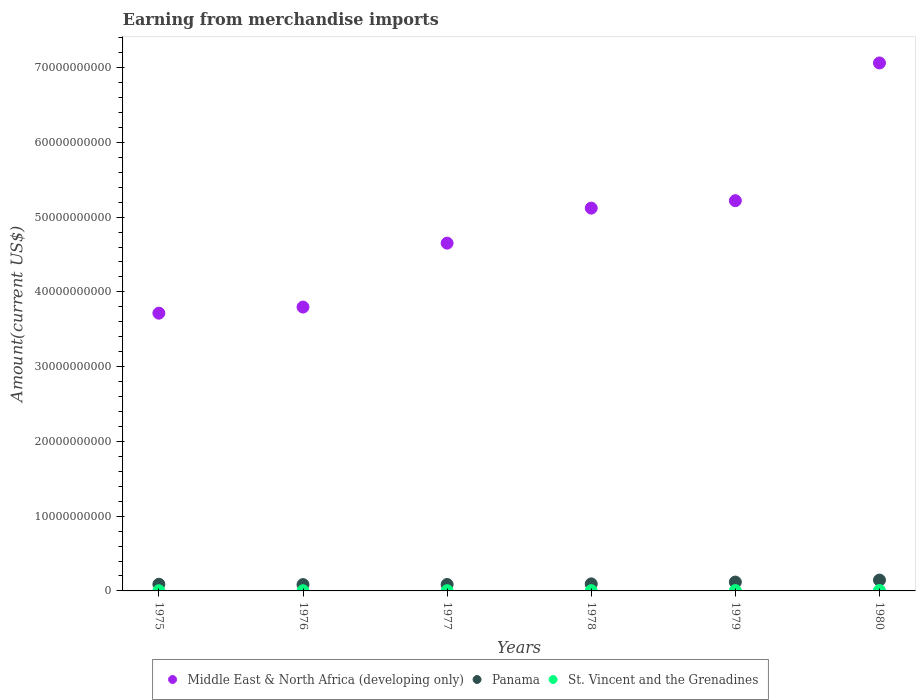How many different coloured dotlines are there?
Keep it short and to the point. 3. Is the number of dotlines equal to the number of legend labels?
Keep it short and to the point. Yes. What is the amount earned from merchandise imports in Middle East & North Africa (developing only) in 1980?
Offer a terse response. 7.06e+1. Across all years, what is the maximum amount earned from merchandise imports in Middle East & North Africa (developing only)?
Ensure brevity in your answer.  7.06e+1. Across all years, what is the minimum amount earned from merchandise imports in Panama?
Provide a short and direct response. 8.48e+08. In which year was the amount earned from merchandise imports in St. Vincent and the Grenadines minimum?
Make the answer very short. 1976. What is the total amount earned from merchandise imports in Panama in the graph?
Offer a very short reply. 6.18e+09. What is the difference between the amount earned from merchandise imports in Middle East & North Africa (developing only) in 1978 and that in 1979?
Provide a succinct answer. -9.95e+08. What is the difference between the amount earned from merchandise imports in Panama in 1979 and the amount earned from merchandise imports in St. Vincent and the Grenadines in 1980?
Ensure brevity in your answer.  1.13e+09. What is the average amount earned from merchandise imports in Panama per year?
Give a very brief answer. 1.03e+09. In the year 1977, what is the difference between the amount earned from merchandise imports in Middle East & North Africa (developing only) and amount earned from merchandise imports in Panama?
Offer a very short reply. 4.57e+1. What is the ratio of the amount earned from merchandise imports in Panama in 1977 to that in 1979?
Make the answer very short. 0.73. Is the amount earned from merchandise imports in Panama in 1978 less than that in 1979?
Keep it short and to the point. Yes. What is the difference between the highest and the second highest amount earned from merchandise imports in Panama?
Ensure brevity in your answer.  2.65e+08. What is the difference between the highest and the lowest amount earned from merchandise imports in Middle East & North Africa (developing only)?
Offer a very short reply. 3.35e+1. In how many years, is the amount earned from merchandise imports in Panama greater than the average amount earned from merchandise imports in Panama taken over all years?
Your response must be concise. 2. Is the sum of the amount earned from merchandise imports in Middle East & North Africa (developing only) in 1975 and 1976 greater than the maximum amount earned from merchandise imports in St. Vincent and the Grenadines across all years?
Keep it short and to the point. Yes. Does the amount earned from merchandise imports in St. Vincent and the Grenadines monotonically increase over the years?
Offer a very short reply. No. Is the amount earned from merchandise imports in Middle East & North Africa (developing only) strictly less than the amount earned from merchandise imports in Panama over the years?
Provide a short and direct response. No. How many years are there in the graph?
Ensure brevity in your answer.  6. Does the graph contain grids?
Your answer should be very brief. No. What is the title of the graph?
Ensure brevity in your answer.  Earning from merchandise imports. What is the label or title of the Y-axis?
Ensure brevity in your answer.  Amount(current US$). What is the Amount(current US$) of Middle East & North Africa (developing only) in 1975?
Make the answer very short. 3.72e+1. What is the Amount(current US$) of Panama in 1975?
Offer a terse response. 8.92e+08. What is the Amount(current US$) of St. Vincent and the Grenadines in 1975?
Keep it short and to the point. 2.48e+07. What is the Amount(current US$) of Middle East & North Africa (developing only) in 1976?
Offer a terse response. 3.80e+1. What is the Amount(current US$) in Panama in 1976?
Your answer should be compact. 8.48e+08. What is the Amount(current US$) of St. Vincent and the Grenadines in 1976?
Your answer should be compact. 2.37e+07. What is the Amount(current US$) in Middle East & North Africa (developing only) in 1977?
Provide a succinct answer. 4.65e+1. What is the Amount(current US$) of Panama in 1977?
Your response must be concise. 8.61e+08. What is the Amount(current US$) of St. Vincent and the Grenadines in 1977?
Give a very brief answer. 3.03e+07. What is the Amount(current US$) of Middle East & North Africa (developing only) in 1978?
Offer a terse response. 5.12e+1. What is the Amount(current US$) in Panama in 1978?
Make the answer very short. 9.42e+08. What is the Amount(current US$) in St. Vincent and the Grenadines in 1978?
Make the answer very short. 3.62e+07. What is the Amount(current US$) in Middle East & North Africa (developing only) in 1979?
Offer a very short reply. 5.22e+1. What is the Amount(current US$) in Panama in 1979?
Ensure brevity in your answer.  1.18e+09. What is the Amount(current US$) in St. Vincent and the Grenadines in 1979?
Give a very brief answer. 4.66e+07. What is the Amount(current US$) in Middle East & North Africa (developing only) in 1980?
Ensure brevity in your answer.  7.06e+1. What is the Amount(current US$) of Panama in 1980?
Give a very brief answer. 1.45e+09. What is the Amount(current US$) in St. Vincent and the Grenadines in 1980?
Ensure brevity in your answer.  5.70e+07. Across all years, what is the maximum Amount(current US$) of Middle East & North Africa (developing only)?
Make the answer very short. 7.06e+1. Across all years, what is the maximum Amount(current US$) of Panama?
Provide a succinct answer. 1.45e+09. Across all years, what is the maximum Amount(current US$) of St. Vincent and the Grenadines?
Offer a terse response. 5.70e+07. Across all years, what is the minimum Amount(current US$) in Middle East & North Africa (developing only)?
Your response must be concise. 3.72e+1. Across all years, what is the minimum Amount(current US$) of Panama?
Your response must be concise. 8.48e+08. Across all years, what is the minimum Amount(current US$) of St. Vincent and the Grenadines?
Give a very brief answer. 2.37e+07. What is the total Amount(current US$) of Middle East & North Africa (developing only) in the graph?
Offer a very short reply. 2.96e+11. What is the total Amount(current US$) in Panama in the graph?
Offer a terse response. 6.18e+09. What is the total Amount(current US$) in St. Vincent and the Grenadines in the graph?
Make the answer very short. 2.19e+08. What is the difference between the Amount(current US$) in Middle East & North Africa (developing only) in 1975 and that in 1976?
Your answer should be compact. -8.16e+08. What is the difference between the Amount(current US$) in Panama in 1975 and that in 1976?
Your answer should be very brief. 4.37e+07. What is the difference between the Amount(current US$) in St. Vincent and the Grenadines in 1975 and that in 1976?
Give a very brief answer. 1.12e+06. What is the difference between the Amount(current US$) of Middle East & North Africa (developing only) in 1975 and that in 1977?
Offer a very short reply. -9.37e+09. What is the difference between the Amount(current US$) of Panama in 1975 and that in 1977?
Make the answer very short. 3.08e+07. What is the difference between the Amount(current US$) of St. Vincent and the Grenadines in 1975 and that in 1977?
Provide a short and direct response. -5.49e+06. What is the difference between the Amount(current US$) in Middle East & North Africa (developing only) in 1975 and that in 1978?
Make the answer very short. -1.41e+1. What is the difference between the Amount(current US$) in Panama in 1975 and that in 1978?
Provide a succinct answer. -5.03e+07. What is the difference between the Amount(current US$) of St. Vincent and the Grenadines in 1975 and that in 1978?
Make the answer very short. -1.13e+07. What is the difference between the Amount(current US$) in Middle East & North Africa (developing only) in 1975 and that in 1979?
Provide a succinct answer. -1.50e+1. What is the difference between the Amount(current US$) of Panama in 1975 and that in 1979?
Provide a short and direct response. -2.92e+08. What is the difference between the Amount(current US$) in St. Vincent and the Grenadines in 1975 and that in 1979?
Your answer should be compact. -2.18e+07. What is the difference between the Amount(current US$) in Middle East & North Africa (developing only) in 1975 and that in 1980?
Ensure brevity in your answer.  -3.35e+1. What is the difference between the Amount(current US$) in Panama in 1975 and that in 1980?
Offer a terse response. -5.57e+08. What is the difference between the Amount(current US$) of St. Vincent and the Grenadines in 1975 and that in 1980?
Your response must be concise. -3.22e+07. What is the difference between the Amount(current US$) of Middle East & North Africa (developing only) in 1976 and that in 1977?
Provide a succinct answer. -8.55e+09. What is the difference between the Amount(current US$) of Panama in 1976 and that in 1977?
Offer a very short reply. -1.29e+07. What is the difference between the Amount(current US$) in St. Vincent and the Grenadines in 1976 and that in 1977?
Give a very brief answer. -6.61e+06. What is the difference between the Amount(current US$) in Middle East & North Africa (developing only) in 1976 and that in 1978?
Offer a terse response. -1.32e+1. What is the difference between the Amount(current US$) in Panama in 1976 and that in 1978?
Offer a very short reply. -9.41e+07. What is the difference between the Amount(current US$) in St. Vincent and the Grenadines in 1976 and that in 1978?
Provide a short and direct response. -1.25e+07. What is the difference between the Amount(current US$) in Middle East & North Africa (developing only) in 1976 and that in 1979?
Your answer should be compact. -1.42e+1. What is the difference between the Amount(current US$) of Panama in 1976 and that in 1979?
Make the answer very short. -3.36e+08. What is the difference between the Amount(current US$) of St. Vincent and the Grenadines in 1976 and that in 1979?
Your answer should be compact. -2.29e+07. What is the difference between the Amount(current US$) of Middle East & North Africa (developing only) in 1976 and that in 1980?
Offer a very short reply. -3.27e+1. What is the difference between the Amount(current US$) of Panama in 1976 and that in 1980?
Make the answer very short. -6.01e+08. What is the difference between the Amount(current US$) of St. Vincent and the Grenadines in 1976 and that in 1980?
Keep it short and to the point. -3.33e+07. What is the difference between the Amount(current US$) of Middle East & North Africa (developing only) in 1977 and that in 1978?
Give a very brief answer. -4.68e+09. What is the difference between the Amount(current US$) of Panama in 1977 and that in 1978?
Your response must be concise. -8.12e+07. What is the difference between the Amount(current US$) in St. Vincent and the Grenadines in 1977 and that in 1978?
Make the answer very short. -5.85e+06. What is the difference between the Amount(current US$) of Middle East & North Africa (developing only) in 1977 and that in 1979?
Your response must be concise. -5.68e+09. What is the difference between the Amount(current US$) of Panama in 1977 and that in 1979?
Provide a succinct answer. -3.23e+08. What is the difference between the Amount(current US$) of St. Vincent and the Grenadines in 1977 and that in 1979?
Offer a very short reply. -1.63e+07. What is the difference between the Amount(current US$) in Middle East & North Africa (developing only) in 1977 and that in 1980?
Provide a short and direct response. -2.41e+1. What is the difference between the Amount(current US$) in Panama in 1977 and that in 1980?
Ensure brevity in your answer.  -5.88e+08. What is the difference between the Amount(current US$) of St. Vincent and the Grenadines in 1977 and that in 1980?
Your response must be concise. -2.67e+07. What is the difference between the Amount(current US$) of Middle East & North Africa (developing only) in 1978 and that in 1979?
Provide a succinct answer. -9.95e+08. What is the difference between the Amount(current US$) in Panama in 1978 and that in 1979?
Ensure brevity in your answer.  -2.41e+08. What is the difference between the Amount(current US$) of St. Vincent and the Grenadines in 1978 and that in 1979?
Make the answer very short. -1.04e+07. What is the difference between the Amount(current US$) in Middle East & North Africa (developing only) in 1978 and that in 1980?
Provide a succinct answer. -1.94e+1. What is the difference between the Amount(current US$) of Panama in 1978 and that in 1980?
Ensure brevity in your answer.  -5.07e+08. What is the difference between the Amount(current US$) in St. Vincent and the Grenadines in 1978 and that in 1980?
Make the answer very short. -2.08e+07. What is the difference between the Amount(current US$) in Middle East & North Africa (developing only) in 1979 and that in 1980?
Make the answer very short. -1.84e+1. What is the difference between the Amount(current US$) of Panama in 1979 and that in 1980?
Your answer should be very brief. -2.65e+08. What is the difference between the Amount(current US$) of St. Vincent and the Grenadines in 1979 and that in 1980?
Your response must be concise. -1.04e+07. What is the difference between the Amount(current US$) in Middle East & North Africa (developing only) in 1975 and the Amount(current US$) in Panama in 1976?
Provide a succinct answer. 3.63e+1. What is the difference between the Amount(current US$) of Middle East & North Africa (developing only) in 1975 and the Amount(current US$) of St. Vincent and the Grenadines in 1976?
Your answer should be compact. 3.71e+1. What is the difference between the Amount(current US$) in Panama in 1975 and the Amount(current US$) in St. Vincent and the Grenadines in 1976?
Provide a short and direct response. 8.68e+08. What is the difference between the Amount(current US$) of Middle East & North Africa (developing only) in 1975 and the Amount(current US$) of Panama in 1977?
Make the answer very short. 3.63e+1. What is the difference between the Amount(current US$) of Middle East & North Africa (developing only) in 1975 and the Amount(current US$) of St. Vincent and the Grenadines in 1977?
Offer a very short reply. 3.71e+1. What is the difference between the Amount(current US$) in Panama in 1975 and the Amount(current US$) in St. Vincent and the Grenadines in 1977?
Your answer should be very brief. 8.62e+08. What is the difference between the Amount(current US$) in Middle East & North Africa (developing only) in 1975 and the Amount(current US$) in Panama in 1978?
Your response must be concise. 3.62e+1. What is the difference between the Amount(current US$) in Middle East & North Africa (developing only) in 1975 and the Amount(current US$) in St. Vincent and the Grenadines in 1978?
Your answer should be compact. 3.71e+1. What is the difference between the Amount(current US$) in Panama in 1975 and the Amount(current US$) in St. Vincent and the Grenadines in 1978?
Offer a very short reply. 8.56e+08. What is the difference between the Amount(current US$) in Middle East & North Africa (developing only) in 1975 and the Amount(current US$) in Panama in 1979?
Ensure brevity in your answer.  3.60e+1. What is the difference between the Amount(current US$) of Middle East & North Africa (developing only) in 1975 and the Amount(current US$) of St. Vincent and the Grenadines in 1979?
Make the answer very short. 3.71e+1. What is the difference between the Amount(current US$) in Panama in 1975 and the Amount(current US$) in St. Vincent and the Grenadines in 1979?
Offer a terse response. 8.45e+08. What is the difference between the Amount(current US$) of Middle East & North Africa (developing only) in 1975 and the Amount(current US$) of Panama in 1980?
Your answer should be compact. 3.57e+1. What is the difference between the Amount(current US$) of Middle East & North Africa (developing only) in 1975 and the Amount(current US$) of St. Vincent and the Grenadines in 1980?
Give a very brief answer. 3.71e+1. What is the difference between the Amount(current US$) of Panama in 1975 and the Amount(current US$) of St. Vincent and the Grenadines in 1980?
Your answer should be compact. 8.35e+08. What is the difference between the Amount(current US$) of Middle East & North Africa (developing only) in 1976 and the Amount(current US$) of Panama in 1977?
Provide a succinct answer. 3.71e+1. What is the difference between the Amount(current US$) in Middle East & North Africa (developing only) in 1976 and the Amount(current US$) in St. Vincent and the Grenadines in 1977?
Offer a very short reply. 3.79e+1. What is the difference between the Amount(current US$) in Panama in 1976 and the Amount(current US$) in St. Vincent and the Grenadines in 1977?
Your answer should be compact. 8.18e+08. What is the difference between the Amount(current US$) of Middle East & North Africa (developing only) in 1976 and the Amount(current US$) of Panama in 1978?
Keep it short and to the point. 3.70e+1. What is the difference between the Amount(current US$) of Middle East & North Africa (developing only) in 1976 and the Amount(current US$) of St. Vincent and the Grenadines in 1978?
Offer a very short reply. 3.79e+1. What is the difference between the Amount(current US$) in Panama in 1976 and the Amount(current US$) in St. Vincent and the Grenadines in 1978?
Ensure brevity in your answer.  8.12e+08. What is the difference between the Amount(current US$) of Middle East & North Africa (developing only) in 1976 and the Amount(current US$) of Panama in 1979?
Give a very brief answer. 3.68e+1. What is the difference between the Amount(current US$) in Middle East & North Africa (developing only) in 1976 and the Amount(current US$) in St. Vincent and the Grenadines in 1979?
Provide a succinct answer. 3.79e+1. What is the difference between the Amount(current US$) of Panama in 1976 and the Amount(current US$) of St. Vincent and the Grenadines in 1979?
Provide a short and direct response. 8.02e+08. What is the difference between the Amount(current US$) in Middle East & North Africa (developing only) in 1976 and the Amount(current US$) in Panama in 1980?
Keep it short and to the point. 3.65e+1. What is the difference between the Amount(current US$) of Middle East & North Africa (developing only) in 1976 and the Amount(current US$) of St. Vincent and the Grenadines in 1980?
Give a very brief answer. 3.79e+1. What is the difference between the Amount(current US$) in Panama in 1976 and the Amount(current US$) in St. Vincent and the Grenadines in 1980?
Offer a terse response. 7.91e+08. What is the difference between the Amount(current US$) of Middle East & North Africa (developing only) in 1977 and the Amount(current US$) of Panama in 1978?
Give a very brief answer. 4.56e+1. What is the difference between the Amount(current US$) of Middle East & North Africa (developing only) in 1977 and the Amount(current US$) of St. Vincent and the Grenadines in 1978?
Provide a succinct answer. 4.65e+1. What is the difference between the Amount(current US$) of Panama in 1977 and the Amount(current US$) of St. Vincent and the Grenadines in 1978?
Offer a very short reply. 8.25e+08. What is the difference between the Amount(current US$) in Middle East & North Africa (developing only) in 1977 and the Amount(current US$) in Panama in 1979?
Ensure brevity in your answer.  4.53e+1. What is the difference between the Amount(current US$) of Middle East & North Africa (developing only) in 1977 and the Amount(current US$) of St. Vincent and the Grenadines in 1979?
Your response must be concise. 4.65e+1. What is the difference between the Amount(current US$) of Panama in 1977 and the Amount(current US$) of St. Vincent and the Grenadines in 1979?
Keep it short and to the point. 8.15e+08. What is the difference between the Amount(current US$) of Middle East & North Africa (developing only) in 1977 and the Amount(current US$) of Panama in 1980?
Give a very brief answer. 4.51e+1. What is the difference between the Amount(current US$) of Middle East & North Africa (developing only) in 1977 and the Amount(current US$) of St. Vincent and the Grenadines in 1980?
Your answer should be compact. 4.65e+1. What is the difference between the Amount(current US$) of Panama in 1977 and the Amount(current US$) of St. Vincent and the Grenadines in 1980?
Offer a terse response. 8.04e+08. What is the difference between the Amount(current US$) of Middle East & North Africa (developing only) in 1978 and the Amount(current US$) of Panama in 1979?
Give a very brief answer. 5.00e+1. What is the difference between the Amount(current US$) in Middle East & North Africa (developing only) in 1978 and the Amount(current US$) in St. Vincent and the Grenadines in 1979?
Your response must be concise. 5.12e+1. What is the difference between the Amount(current US$) in Panama in 1978 and the Amount(current US$) in St. Vincent and the Grenadines in 1979?
Keep it short and to the point. 8.96e+08. What is the difference between the Amount(current US$) in Middle East & North Africa (developing only) in 1978 and the Amount(current US$) in Panama in 1980?
Keep it short and to the point. 4.98e+1. What is the difference between the Amount(current US$) of Middle East & North Africa (developing only) in 1978 and the Amount(current US$) of St. Vincent and the Grenadines in 1980?
Keep it short and to the point. 5.11e+1. What is the difference between the Amount(current US$) of Panama in 1978 and the Amount(current US$) of St. Vincent and the Grenadines in 1980?
Make the answer very short. 8.85e+08. What is the difference between the Amount(current US$) in Middle East & North Africa (developing only) in 1979 and the Amount(current US$) in Panama in 1980?
Your answer should be compact. 5.07e+1. What is the difference between the Amount(current US$) of Middle East & North Africa (developing only) in 1979 and the Amount(current US$) of St. Vincent and the Grenadines in 1980?
Keep it short and to the point. 5.21e+1. What is the difference between the Amount(current US$) in Panama in 1979 and the Amount(current US$) in St. Vincent and the Grenadines in 1980?
Provide a succinct answer. 1.13e+09. What is the average Amount(current US$) of Middle East & North Africa (developing only) per year?
Ensure brevity in your answer.  4.93e+1. What is the average Amount(current US$) of Panama per year?
Your response must be concise. 1.03e+09. What is the average Amount(current US$) in St. Vincent and the Grenadines per year?
Your answer should be compact. 3.64e+07. In the year 1975, what is the difference between the Amount(current US$) of Middle East & North Africa (developing only) and Amount(current US$) of Panama?
Give a very brief answer. 3.63e+1. In the year 1975, what is the difference between the Amount(current US$) of Middle East & North Africa (developing only) and Amount(current US$) of St. Vincent and the Grenadines?
Provide a short and direct response. 3.71e+1. In the year 1975, what is the difference between the Amount(current US$) of Panama and Amount(current US$) of St. Vincent and the Grenadines?
Ensure brevity in your answer.  8.67e+08. In the year 1976, what is the difference between the Amount(current US$) of Middle East & North Africa (developing only) and Amount(current US$) of Panama?
Your answer should be very brief. 3.71e+1. In the year 1976, what is the difference between the Amount(current US$) in Middle East & North Africa (developing only) and Amount(current US$) in St. Vincent and the Grenadines?
Give a very brief answer. 3.79e+1. In the year 1976, what is the difference between the Amount(current US$) in Panama and Amount(current US$) in St. Vincent and the Grenadines?
Provide a short and direct response. 8.25e+08. In the year 1977, what is the difference between the Amount(current US$) of Middle East & North Africa (developing only) and Amount(current US$) of Panama?
Make the answer very short. 4.57e+1. In the year 1977, what is the difference between the Amount(current US$) of Middle East & North Africa (developing only) and Amount(current US$) of St. Vincent and the Grenadines?
Provide a succinct answer. 4.65e+1. In the year 1977, what is the difference between the Amount(current US$) of Panama and Amount(current US$) of St. Vincent and the Grenadines?
Offer a terse response. 8.31e+08. In the year 1978, what is the difference between the Amount(current US$) of Middle East & North Africa (developing only) and Amount(current US$) of Panama?
Offer a terse response. 5.03e+1. In the year 1978, what is the difference between the Amount(current US$) in Middle East & North Africa (developing only) and Amount(current US$) in St. Vincent and the Grenadines?
Make the answer very short. 5.12e+1. In the year 1978, what is the difference between the Amount(current US$) in Panama and Amount(current US$) in St. Vincent and the Grenadines?
Your answer should be compact. 9.06e+08. In the year 1979, what is the difference between the Amount(current US$) in Middle East & North Africa (developing only) and Amount(current US$) in Panama?
Your answer should be compact. 5.10e+1. In the year 1979, what is the difference between the Amount(current US$) in Middle East & North Africa (developing only) and Amount(current US$) in St. Vincent and the Grenadines?
Your response must be concise. 5.22e+1. In the year 1979, what is the difference between the Amount(current US$) of Panama and Amount(current US$) of St. Vincent and the Grenadines?
Your response must be concise. 1.14e+09. In the year 1980, what is the difference between the Amount(current US$) of Middle East & North Africa (developing only) and Amount(current US$) of Panama?
Make the answer very short. 6.92e+1. In the year 1980, what is the difference between the Amount(current US$) in Middle East & North Africa (developing only) and Amount(current US$) in St. Vincent and the Grenadines?
Give a very brief answer. 7.06e+1. In the year 1980, what is the difference between the Amount(current US$) in Panama and Amount(current US$) in St. Vincent and the Grenadines?
Give a very brief answer. 1.39e+09. What is the ratio of the Amount(current US$) of Middle East & North Africa (developing only) in 1975 to that in 1976?
Your answer should be compact. 0.98. What is the ratio of the Amount(current US$) in Panama in 1975 to that in 1976?
Give a very brief answer. 1.05. What is the ratio of the Amount(current US$) of St. Vincent and the Grenadines in 1975 to that in 1976?
Your response must be concise. 1.05. What is the ratio of the Amount(current US$) in Middle East & North Africa (developing only) in 1975 to that in 1977?
Your answer should be very brief. 0.8. What is the ratio of the Amount(current US$) of Panama in 1975 to that in 1977?
Your answer should be compact. 1.04. What is the ratio of the Amount(current US$) in St. Vincent and the Grenadines in 1975 to that in 1977?
Your response must be concise. 0.82. What is the ratio of the Amount(current US$) of Middle East & North Africa (developing only) in 1975 to that in 1978?
Provide a short and direct response. 0.73. What is the ratio of the Amount(current US$) of Panama in 1975 to that in 1978?
Offer a terse response. 0.95. What is the ratio of the Amount(current US$) of St. Vincent and the Grenadines in 1975 to that in 1978?
Keep it short and to the point. 0.69. What is the ratio of the Amount(current US$) in Middle East & North Africa (developing only) in 1975 to that in 1979?
Keep it short and to the point. 0.71. What is the ratio of the Amount(current US$) of Panama in 1975 to that in 1979?
Give a very brief answer. 0.75. What is the ratio of the Amount(current US$) of St. Vincent and the Grenadines in 1975 to that in 1979?
Keep it short and to the point. 0.53. What is the ratio of the Amount(current US$) in Middle East & North Africa (developing only) in 1975 to that in 1980?
Your answer should be very brief. 0.53. What is the ratio of the Amount(current US$) in Panama in 1975 to that in 1980?
Your response must be concise. 0.62. What is the ratio of the Amount(current US$) in St. Vincent and the Grenadines in 1975 to that in 1980?
Provide a succinct answer. 0.44. What is the ratio of the Amount(current US$) of Middle East & North Africa (developing only) in 1976 to that in 1977?
Make the answer very short. 0.82. What is the ratio of the Amount(current US$) of St. Vincent and the Grenadines in 1976 to that in 1977?
Your answer should be compact. 0.78. What is the ratio of the Amount(current US$) in Middle East & North Africa (developing only) in 1976 to that in 1978?
Provide a succinct answer. 0.74. What is the ratio of the Amount(current US$) of Panama in 1976 to that in 1978?
Provide a short and direct response. 0.9. What is the ratio of the Amount(current US$) of St. Vincent and the Grenadines in 1976 to that in 1978?
Provide a succinct answer. 0.66. What is the ratio of the Amount(current US$) in Middle East & North Africa (developing only) in 1976 to that in 1979?
Your answer should be very brief. 0.73. What is the ratio of the Amount(current US$) in Panama in 1976 to that in 1979?
Ensure brevity in your answer.  0.72. What is the ratio of the Amount(current US$) in St. Vincent and the Grenadines in 1976 to that in 1979?
Give a very brief answer. 0.51. What is the ratio of the Amount(current US$) of Middle East & North Africa (developing only) in 1976 to that in 1980?
Keep it short and to the point. 0.54. What is the ratio of the Amount(current US$) in Panama in 1976 to that in 1980?
Provide a succinct answer. 0.59. What is the ratio of the Amount(current US$) of St. Vincent and the Grenadines in 1976 to that in 1980?
Offer a terse response. 0.42. What is the ratio of the Amount(current US$) of Middle East & North Africa (developing only) in 1977 to that in 1978?
Provide a short and direct response. 0.91. What is the ratio of the Amount(current US$) in Panama in 1977 to that in 1978?
Offer a terse response. 0.91. What is the ratio of the Amount(current US$) in St. Vincent and the Grenadines in 1977 to that in 1978?
Your response must be concise. 0.84. What is the ratio of the Amount(current US$) of Middle East & North Africa (developing only) in 1977 to that in 1979?
Offer a very short reply. 0.89. What is the ratio of the Amount(current US$) of Panama in 1977 to that in 1979?
Offer a very short reply. 0.73. What is the ratio of the Amount(current US$) in St. Vincent and the Grenadines in 1977 to that in 1979?
Your answer should be compact. 0.65. What is the ratio of the Amount(current US$) of Middle East & North Africa (developing only) in 1977 to that in 1980?
Your answer should be very brief. 0.66. What is the ratio of the Amount(current US$) of Panama in 1977 to that in 1980?
Offer a very short reply. 0.59. What is the ratio of the Amount(current US$) in St. Vincent and the Grenadines in 1977 to that in 1980?
Your answer should be compact. 0.53. What is the ratio of the Amount(current US$) in Middle East & North Africa (developing only) in 1978 to that in 1979?
Provide a succinct answer. 0.98. What is the ratio of the Amount(current US$) of Panama in 1978 to that in 1979?
Offer a very short reply. 0.8. What is the ratio of the Amount(current US$) in St. Vincent and the Grenadines in 1978 to that in 1979?
Ensure brevity in your answer.  0.78. What is the ratio of the Amount(current US$) in Middle East & North Africa (developing only) in 1978 to that in 1980?
Provide a short and direct response. 0.73. What is the ratio of the Amount(current US$) of Panama in 1978 to that in 1980?
Provide a succinct answer. 0.65. What is the ratio of the Amount(current US$) in St. Vincent and the Grenadines in 1978 to that in 1980?
Give a very brief answer. 0.63. What is the ratio of the Amount(current US$) in Middle East & North Africa (developing only) in 1979 to that in 1980?
Your answer should be compact. 0.74. What is the ratio of the Amount(current US$) of Panama in 1979 to that in 1980?
Ensure brevity in your answer.  0.82. What is the ratio of the Amount(current US$) of St. Vincent and the Grenadines in 1979 to that in 1980?
Provide a succinct answer. 0.82. What is the difference between the highest and the second highest Amount(current US$) in Middle East & North Africa (developing only)?
Your answer should be very brief. 1.84e+1. What is the difference between the highest and the second highest Amount(current US$) in Panama?
Ensure brevity in your answer.  2.65e+08. What is the difference between the highest and the second highest Amount(current US$) of St. Vincent and the Grenadines?
Provide a short and direct response. 1.04e+07. What is the difference between the highest and the lowest Amount(current US$) of Middle East & North Africa (developing only)?
Your answer should be compact. 3.35e+1. What is the difference between the highest and the lowest Amount(current US$) of Panama?
Keep it short and to the point. 6.01e+08. What is the difference between the highest and the lowest Amount(current US$) of St. Vincent and the Grenadines?
Offer a terse response. 3.33e+07. 